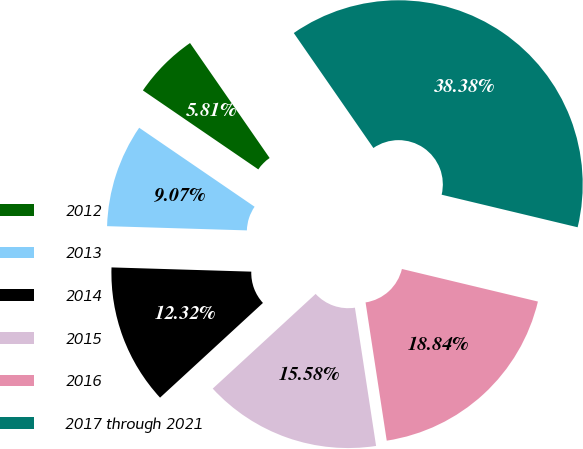Convert chart to OTSL. <chart><loc_0><loc_0><loc_500><loc_500><pie_chart><fcel>2012<fcel>2013<fcel>2014<fcel>2015<fcel>2016<fcel>2017 through 2021<nl><fcel>5.81%<fcel>9.07%<fcel>12.32%<fcel>15.58%<fcel>18.84%<fcel>38.38%<nl></chart> 